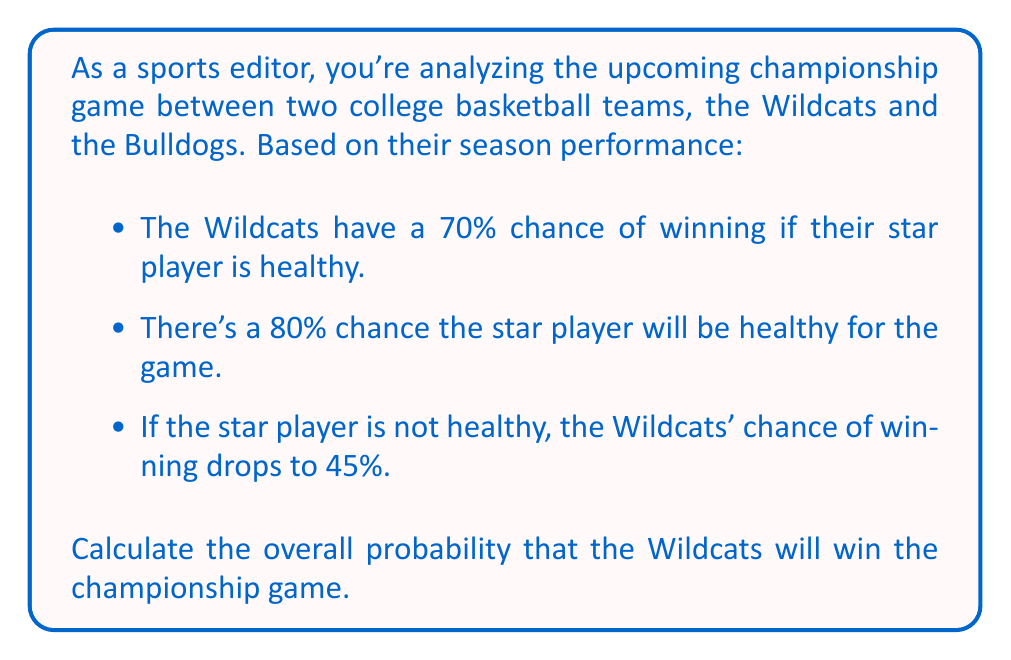Solve this math problem. Let's approach this step-by-step using the law of total probability:

1) Define events:
   - Let W be the event "Wildcats win"
   - Let H be the event "Star player is healthy"

2) We're given:
   - P(W|H) = 0.70 (probability of Wildcats winning if star player is healthy)
   - P(H) = 0.80 (probability star player is healthy)
   - P(W|not H) = 0.45 (probability of Wildcats winning if star player is not healthy)

3) We can calculate P(not H):
   P(not H) = 1 - P(H) = 1 - 0.80 = 0.20

4) Using the law of total probability:
   P(W) = P(W|H) * P(H) + P(W|not H) * P(not H)

5) Substituting the values:
   P(W) = 0.70 * 0.80 + 0.45 * 0.20

6) Calculating:
   P(W) = 0.56 + 0.09 = 0.65

Therefore, the overall probability that the Wildcats will win the championship game is 0.65 or 65%.
Answer: The overall probability that the Wildcats will win the championship game is 0.65 or 65%. 